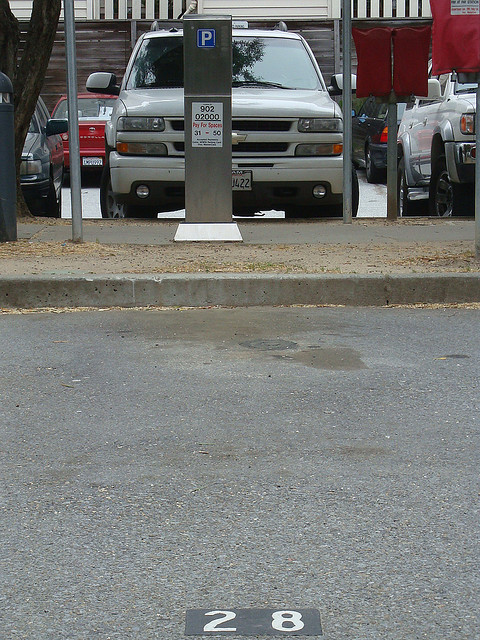Please identify all text content in this image. p 802 02000 28 1422 